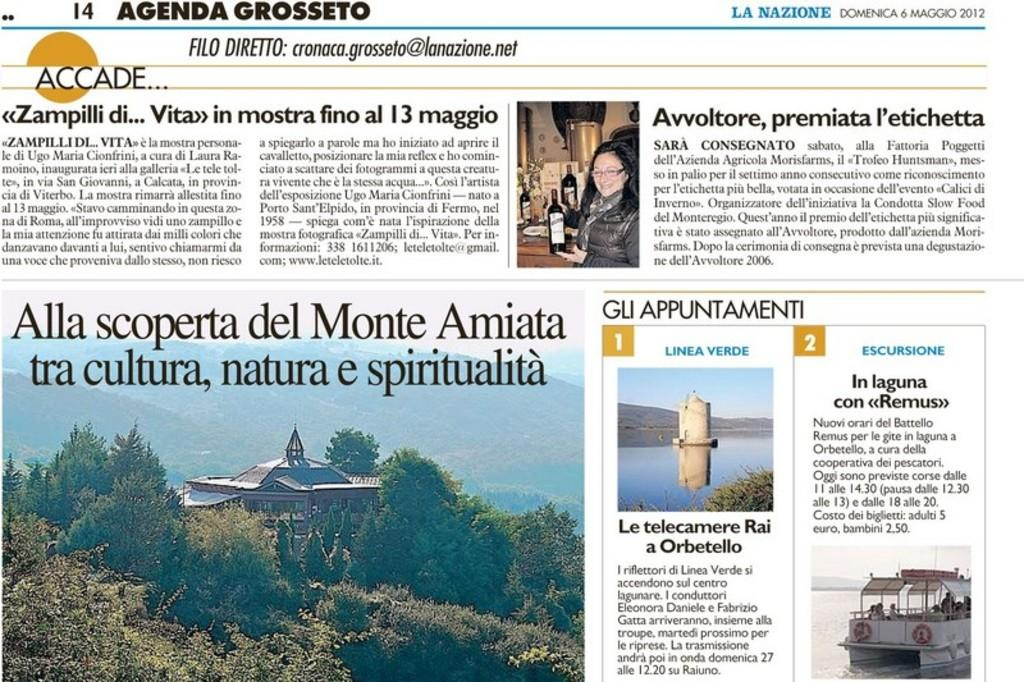Provide a one-sentence caption for the provided image. Agenda Grosseto shows photos and articles from the year 2012. 